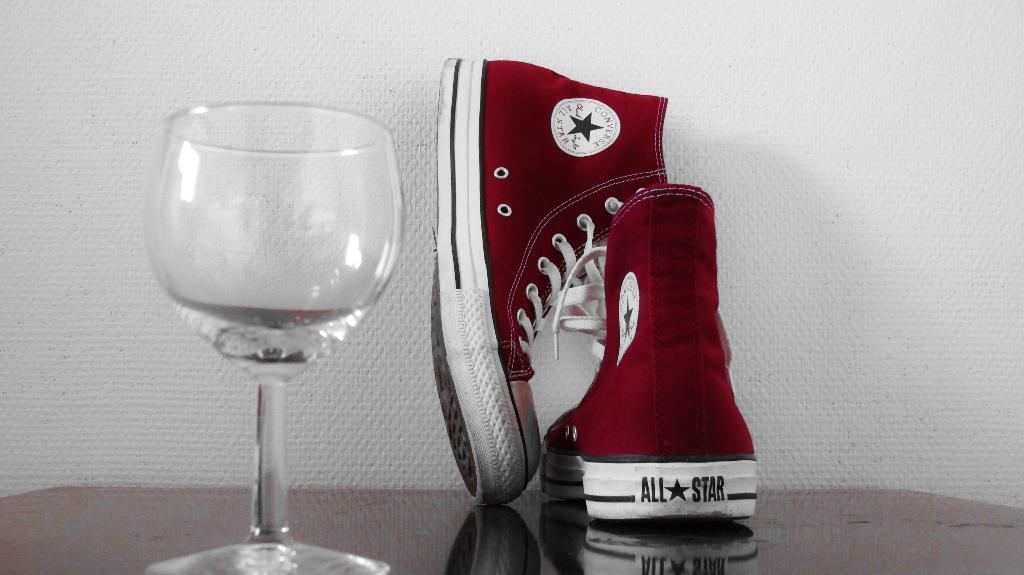Could you give a brief overview of what you see in this image? In this image we can see shoes and a glass on the table and wall in the background. 